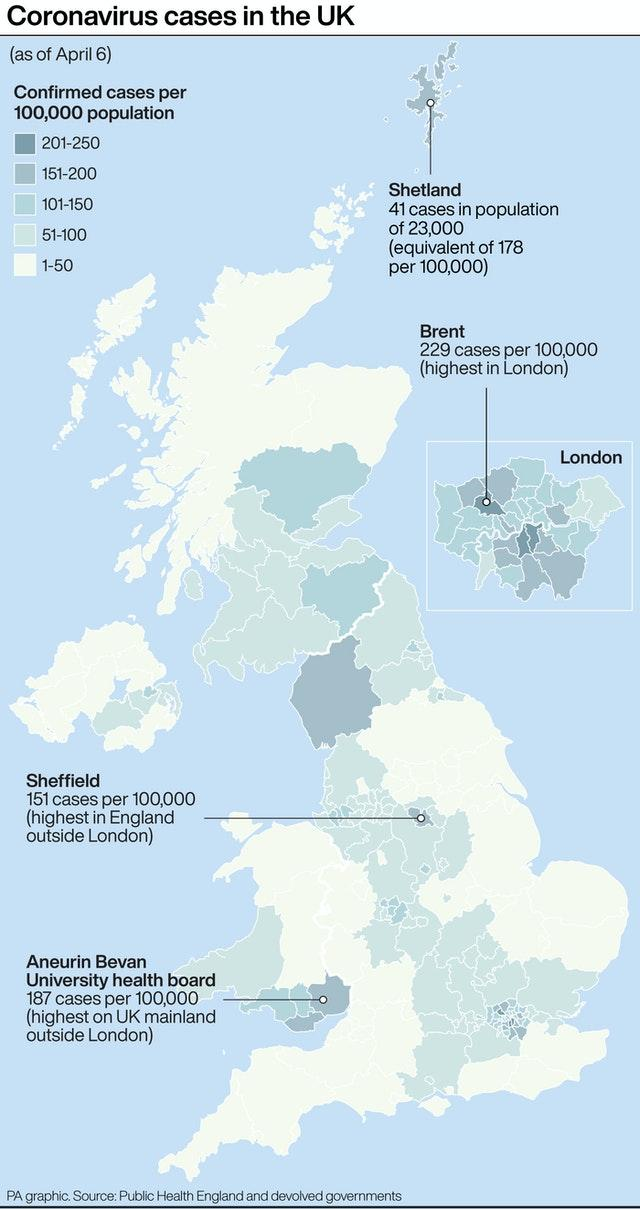Specify some key components in this picture. The Aneurin Bevan University Health Board has the highest number of cases per 100,000 population among the places shown on the map, with a rate of 150-200 cases per 100,000 population. There are approximately three places shown on the map that have a higher incidence of cases per 100,000 population between 150 and 200. There is a place shown on the map that has more than 200 cases per 100,000 population. This place is Brent. Sheffield has the lowest number of cases per 100,000 population among the places shown in the map with a range of 150-200 cases per 100,000 population. The map shows a significant number of places with populations exceeding 200 cases per 100,000 inhabitants. 